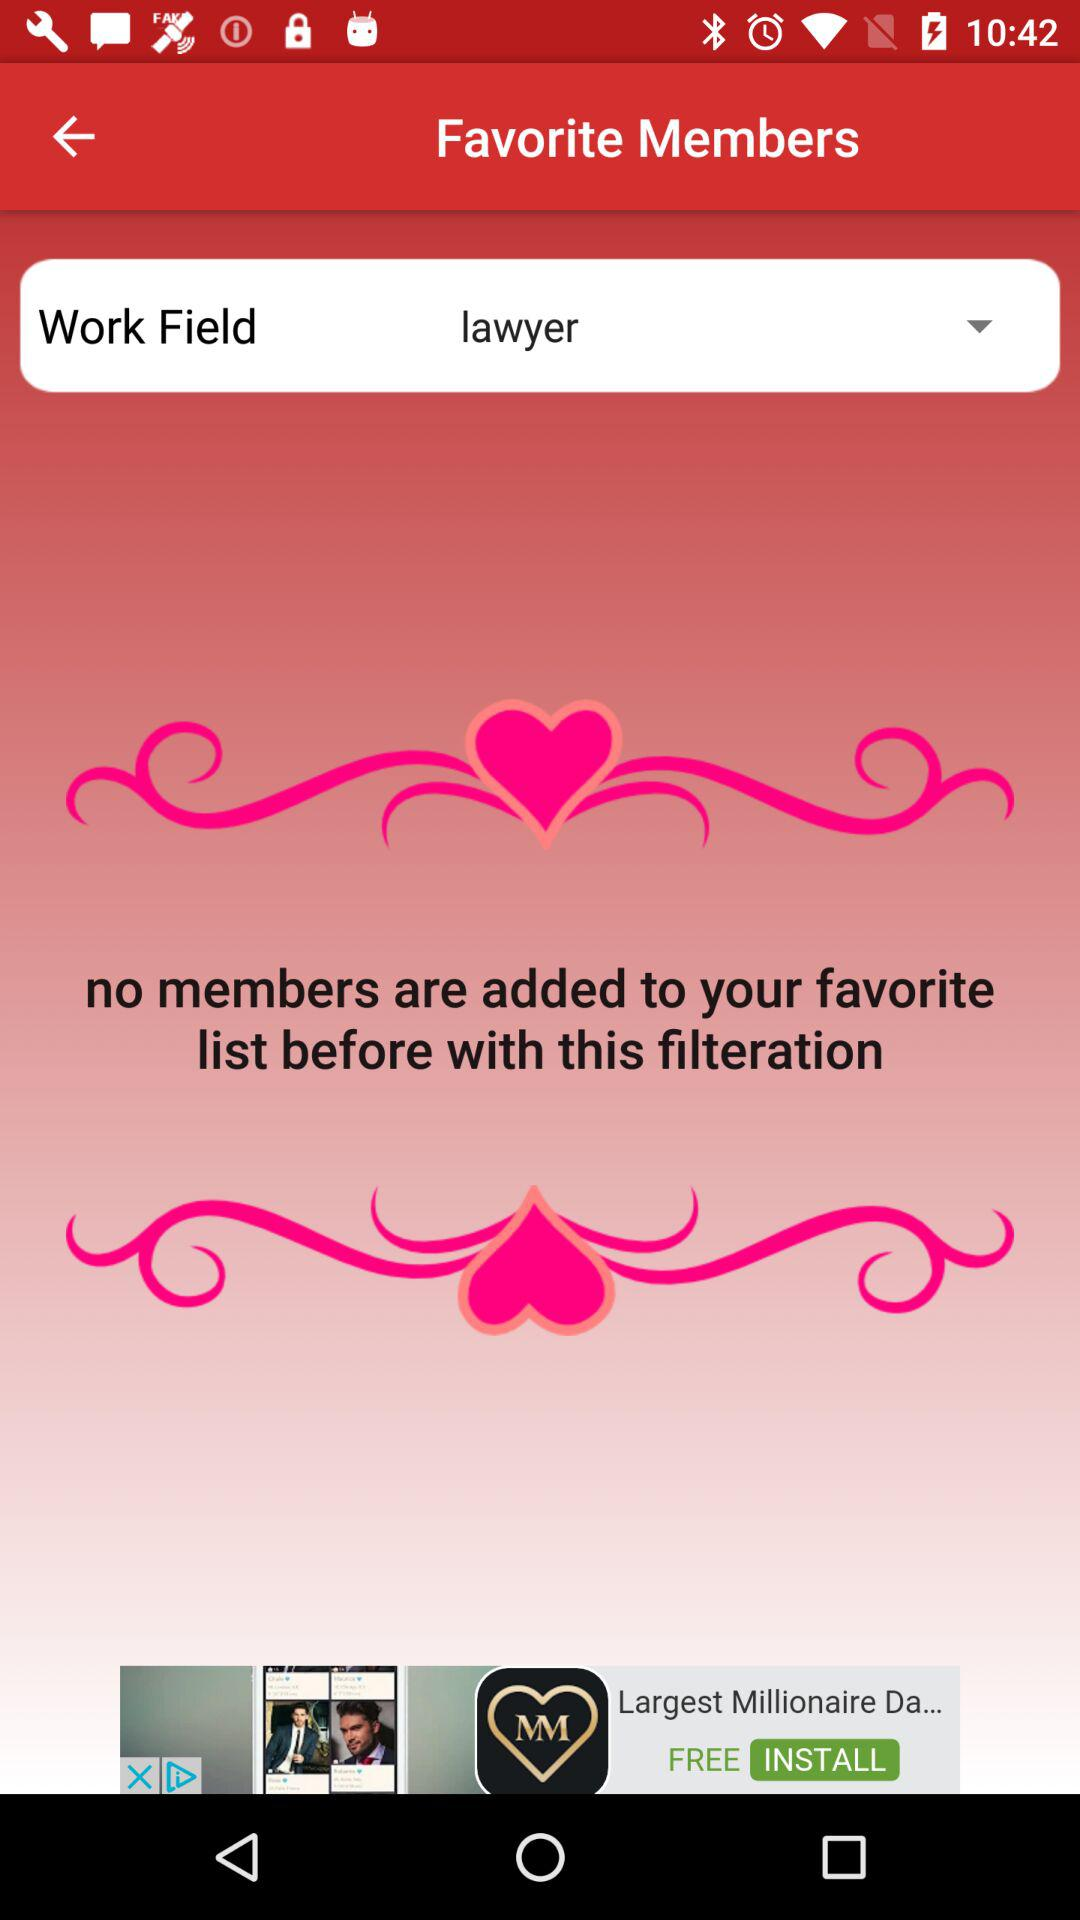What is the selected option for "Work Field"? The selected option for "Work Field" is "lawyer". 